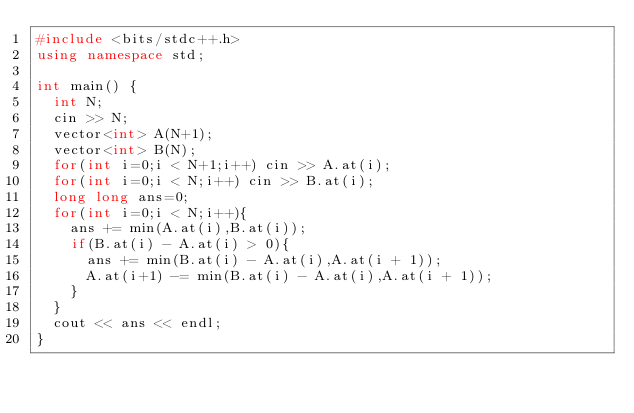<code> <loc_0><loc_0><loc_500><loc_500><_C++_>#include <bits/stdc++.h>
using namespace std;
 
int main() {
  int N;
  cin >> N;
  vector<int> A(N+1);
  vector<int> B(N);
  for(int i=0;i < N+1;i++) cin >> A.at(i);
  for(int i=0;i < N;i++) cin >> B.at(i);
  long long ans=0;
  for(int i=0;i < N;i++){
    ans += min(A.at(i),B.at(i));
    if(B.at(i) - A.at(i) > 0){
      ans += min(B.at(i) - A.at(i),A.at(i + 1));
      A.at(i+1) -= min(B.at(i) - A.at(i),A.at(i + 1));
    }
  }
  cout << ans << endl;
}</code> 